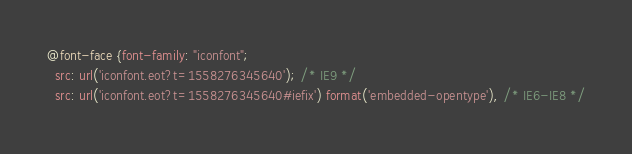<code> <loc_0><loc_0><loc_500><loc_500><_CSS_>@font-face {font-family: "iconfont";
  src: url('iconfont.eot?t=1558276345640'); /* IE9 */
  src: url('iconfont.eot?t=1558276345640#iefix') format('embedded-opentype'), /* IE6-IE8 */</code> 